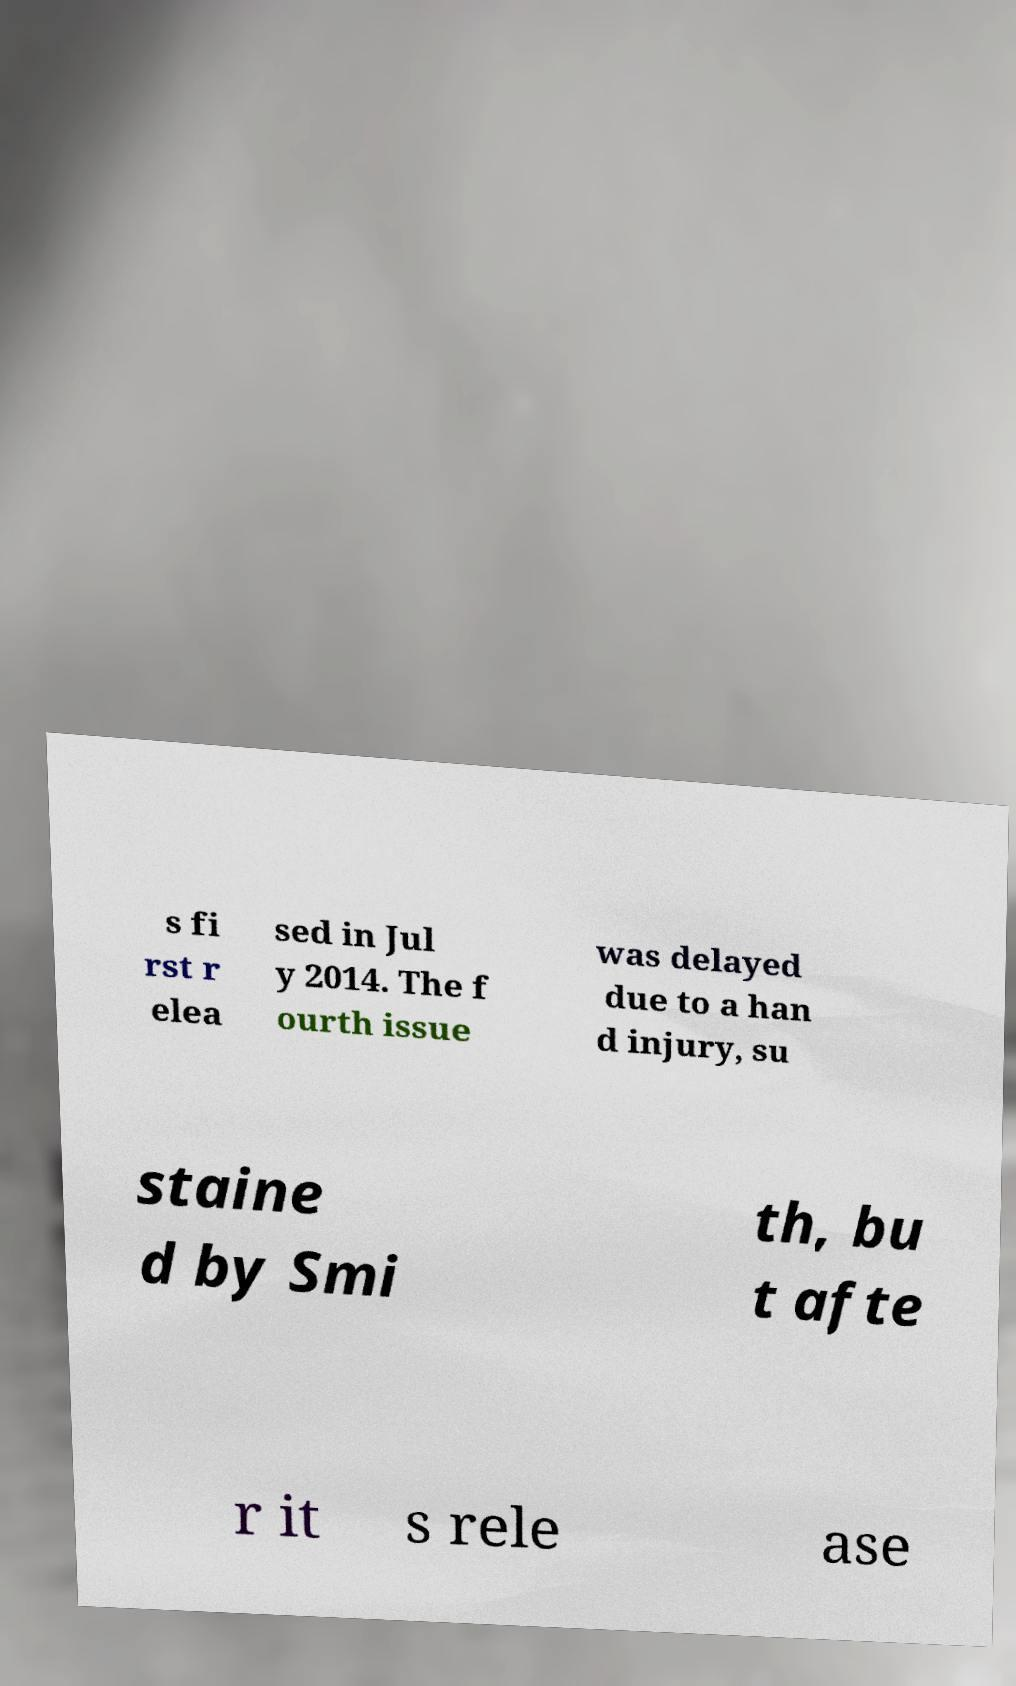For documentation purposes, I need the text within this image transcribed. Could you provide that? s fi rst r elea sed in Jul y 2014. The f ourth issue was delayed due to a han d injury, su staine d by Smi th, bu t afte r it s rele ase 